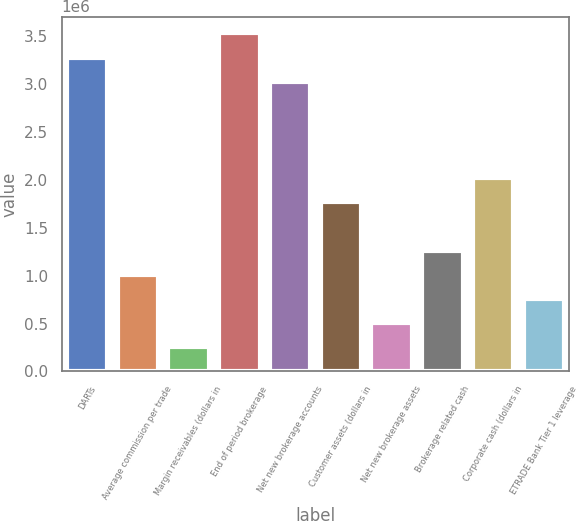Convert chart to OTSL. <chart><loc_0><loc_0><loc_500><loc_500><bar_chart><fcel>DARTs<fcel>Average commission per trade<fcel>Margin receivables (dollars in<fcel>End of period brokerage<fcel>Net new brokerage accounts<fcel>Customer assets (dollars in<fcel>Net new brokerage assets<fcel>Brokerage related cash<fcel>Corporate cash (dollars in<fcel>ETRADE Bank Tier 1 leverage<nl><fcel>3.27055e+06<fcel>1.00632e+06<fcel>251583<fcel>3.52213e+06<fcel>3.01897e+06<fcel>1.76106e+06<fcel>503163<fcel>1.2579e+06<fcel>2.01265e+06<fcel>754744<nl></chart> 